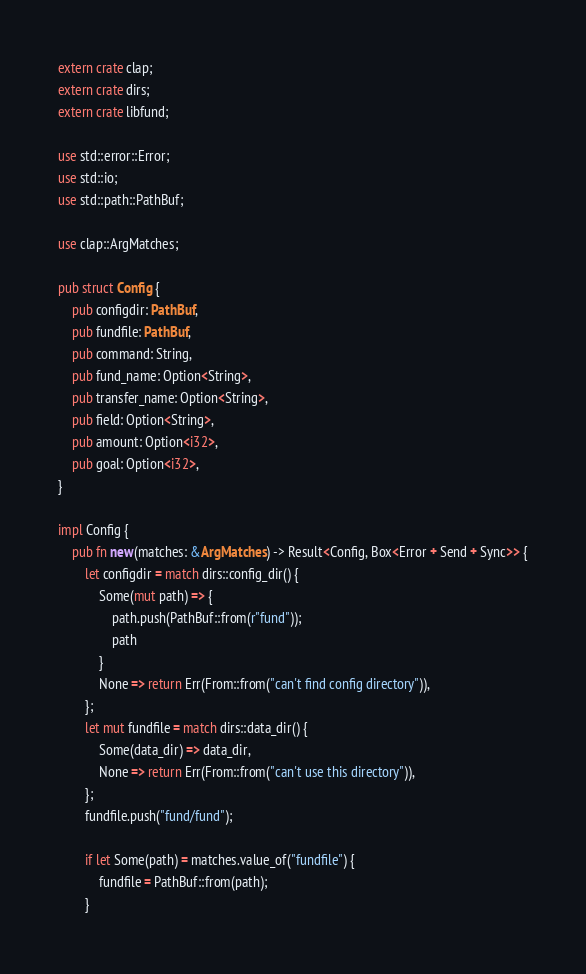Convert code to text. <code><loc_0><loc_0><loc_500><loc_500><_Rust_>extern crate clap;
extern crate dirs;
extern crate libfund;

use std::error::Error;
use std::io;
use std::path::PathBuf;

use clap::ArgMatches;

pub struct Config {
    pub configdir: PathBuf,
    pub fundfile: PathBuf,
    pub command: String,
    pub fund_name: Option<String>,
    pub transfer_name: Option<String>,
    pub field: Option<String>,
    pub amount: Option<i32>,
    pub goal: Option<i32>,
}

impl Config {
    pub fn new(matches: &ArgMatches) -> Result<Config, Box<Error + Send + Sync>> {
        let configdir = match dirs::config_dir() {
            Some(mut path) => {
                path.push(PathBuf::from(r"fund"));
                path
            }
            None => return Err(From::from("can't find config directory")),
        };
        let mut fundfile = match dirs::data_dir() {
            Some(data_dir) => data_dir,
            None => return Err(From::from("can't use this directory")),
        };
        fundfile.push("fund/fund");
        
        if let Some(path) = matches.value_of("fundfile") {
            fundfile = PathBuf::from(path);
        }
</code> 